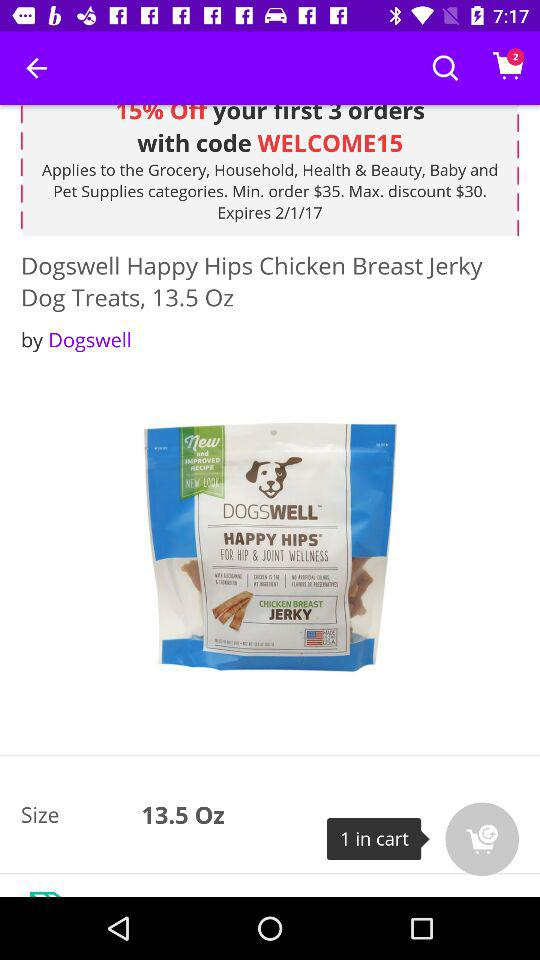How many items in total are there in the cart? There are 2 items in the cart. 